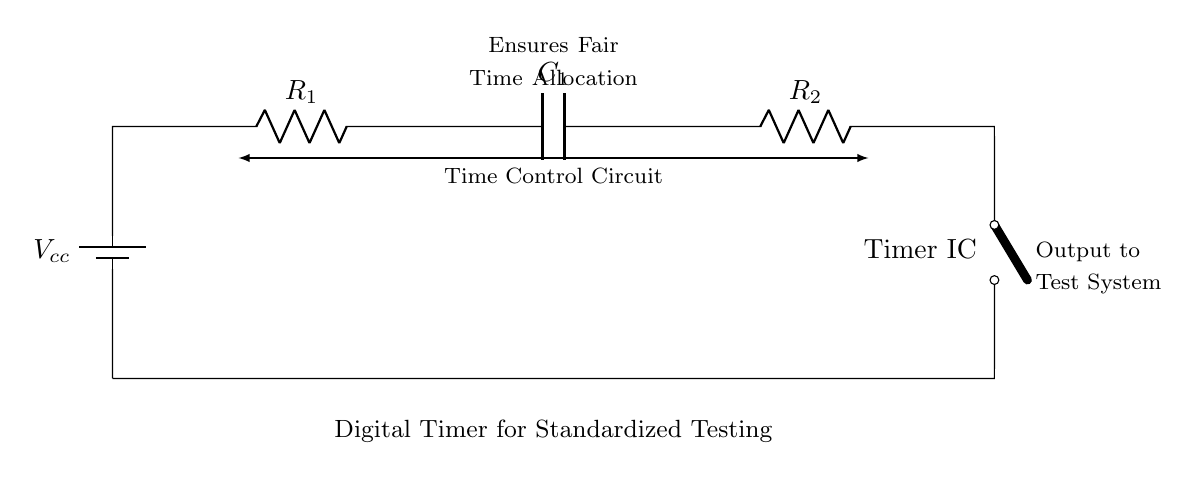What is the purpose of the digital timer in the circuit? The digital timer ensures fair time allocation during standardized testing by controlling the duration of the test.
Answer: Fair time allocation What components are present in the series circuit? The components include a battery, two resistors, a capacitor, and a timer integrated circuit.
Answer: Battery, resistors, capacitor, timer IC How many resistors are used in the circuit? There are two resistors labeled R1 and R2.
Answer: Two What is the role of the capacitor in the circuit? The capacitor is used to store charge, which helps in timing the duration for the digital timer function.
Answer: Store charge What type of circuit is represented here? The circuit is a series circuit where all components are connected in a single path for current flow.
Answer: Series circuit What does the output of the timer connect to? The output connects to the test system, indicating the timer's control of the testing duration.
Answer: Test system Explain how the time control function is achieved in this series circuit. The timing is managed through the combination of R1, R2, and C1, where the resistor-capacitor network determines the charging and discharging time, influencing the timer IC's operation and thereby controlling the time allocated for the test.
Answer: R1, R2, C1 